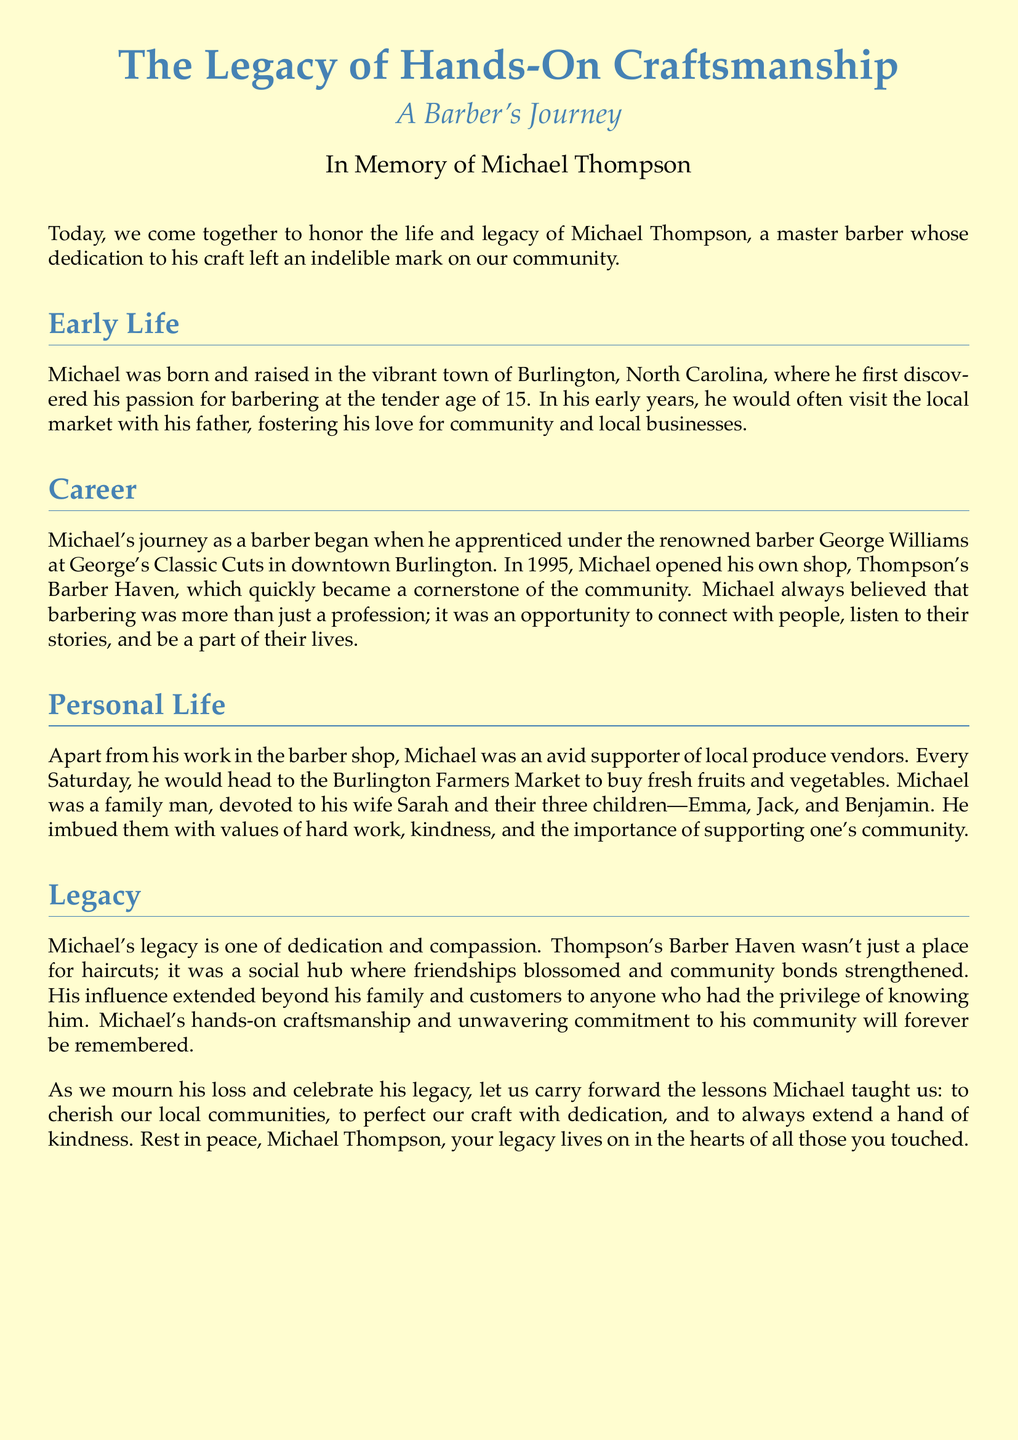what is the name of the barber being honored? The document honors Michael Thompson, stating his name at the beginning and throughout.
Answer: Michael Thompson where did Michael Thompson begin his apprenticeship? The document mentions that Michael apprenticed under George Williams at a specific barbershop.
Answer: George's Classic Cuts what year did Michael open his own shop? The document provides the year Michael opened Thompson's Barber Haven, specifying a key milestone in his career.
Answer: 1995 what values did Michael pass on to his children? The document highlights the important values Michael instilled in his family, reflecting his personal beliefs.
Answer: hard work, kindness, and the importance of supporting one's community how many children did Michael have? The document explicitly states the number of children Michael had while discussing his personal life.
Answer: three what was the name of Michael's barber shop? The document names Michael's barbershop as part of his legacy and community impact.
Answer: Thompson's Barber Haven what market did Michael visit every Saturday? The document specifies a location where Michael frequented to support local vendors.
Answer: Burlington Farmers Market how did Michael contribute to his community? The document describes Michael's approach to barbering and community interaction, indicating his role beyond just a haircut.
Answer: connections and friendships 